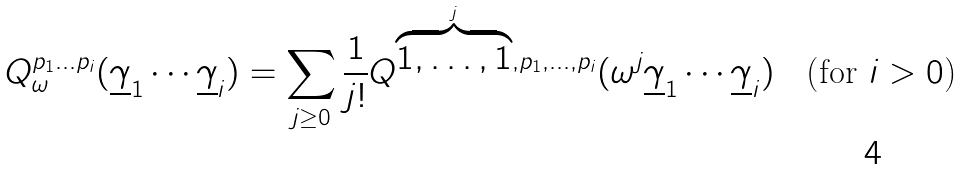Convert formula to latex. <formula><loc_0><loc_0><loc_500><loc_500>Q _ { \omega } ^ { p _ { 1 } \dots p _ { i } } ( \underline { \gamma } _ { 1 } \cdots \underline { \gamma } _ { i } ) = \sum _ { j \geq 0 } \frac { 1 } { j ! } Q ^ { \overbrace { 1 , \dots , 1 } ^ { j } , p _ { 1 } , \dots , p _ { i } } ( \omega ^ { j } \underline { \gamma } _ { 1 } \cdots \underline { \gamma } _ { i } ) \quad \text {(for $i>0$)}</formula> 